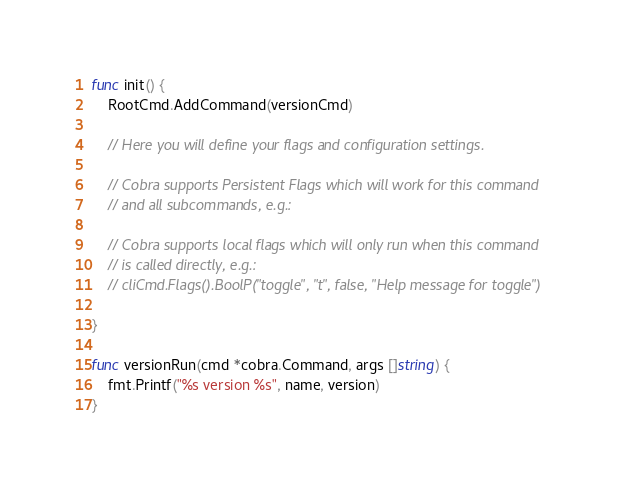Convert code to text. <code><loc_0><loc_0><loc_500><loc_500><_Go_>
func init() {
	RootCmd.AddCommand(versionCmd)

	// Here you will define your flags and configuration settings.

	// Cobra supports Persistent Flags which will work for this command
	// and all subcommands, e.g.:

	// Cobra supports local flags which will only run when this command
	// is called directly, e.g.:
	// cliCmd.Flags().BoolP("toggle", "t", false, "Help message for toggle")

}

func versionRun(cmd *cobra.Command, args []string) {
	fmt.Printf("%s version %s", name, version)
}
</code> 